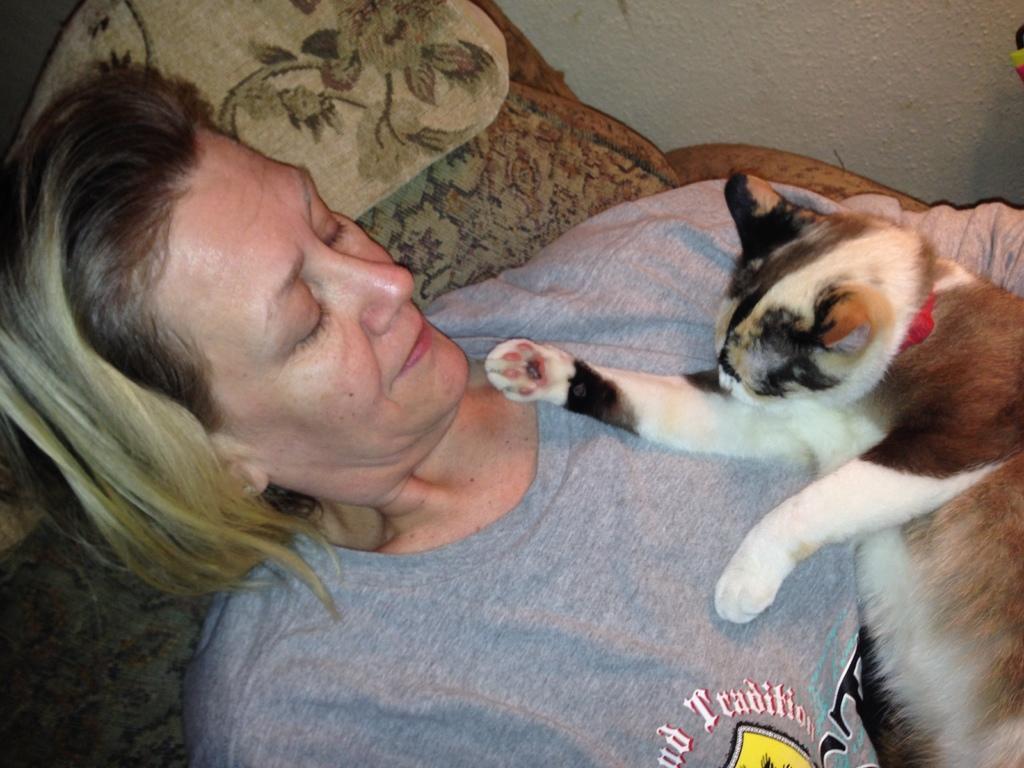In one or two sentences, can you explain what this image depicts? Here we can see one woman lying on a blanket and there is a cat on her. This is a wall. 